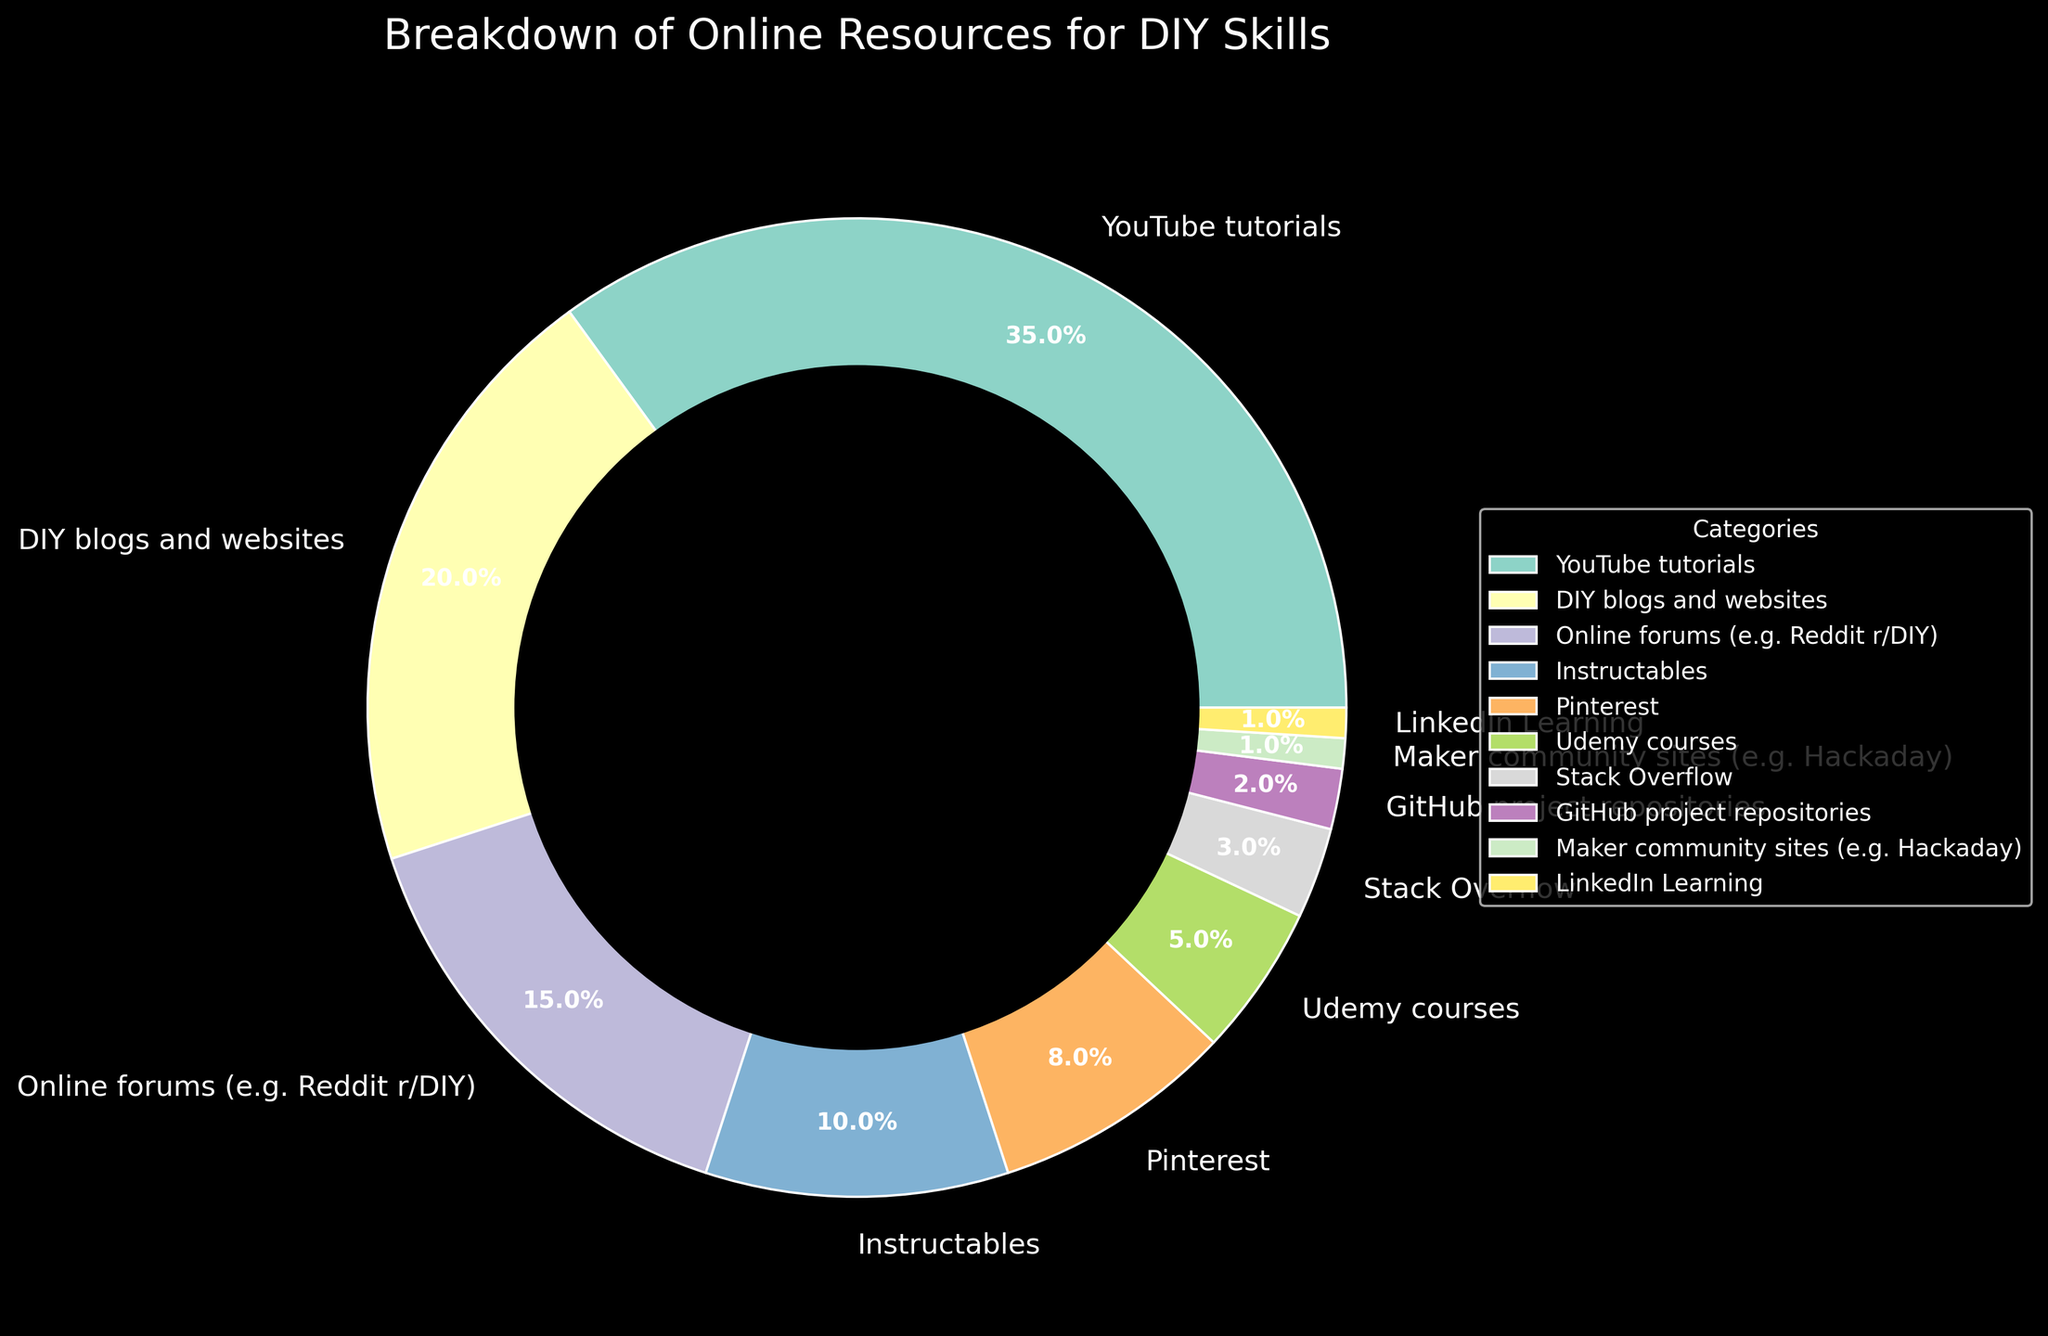What's the combined percentage of YouTube tutorials and DIY blogs and websites? YouTube tutorials account for 35% and DIY blogs and websites account for 20%. To find the combined percentage, add these two values together: 35% + 20% = 55%.
Answer: 55% Which online resource has the smallest percentage? The figure shows that LinkedIn Learning and Maker community sites (e.g., Hackaday) both have the smallest percentage, at 1%.
Answer: LinkedIn Learning and Maker community sites What is the difference in percentage between Instructables and Stack Overflow? Instructables account for 10% and Stack Overflow accounts for 3%. The difference in percentage is calculated as 10% - 3% = 7%.
Answer: 7% Which online resource category has a higher percentage, Pinterest or Udemy courses? From the figure, Pinterest has an 8% share, while Udemy courses have a 5% share. Therefore, Pinterest has a higher percentage.
Answer: Pinterest How much more popular is YouTube tutorials compared to online forums (e.g., Reddit r/DIY)? YouTube tutorials have a percentage of 35%, and online forums (e.g., Reddit r/DIY) have 15%. The difference is 35% - 15% = 20%.
Answer: 20% What is the total percentage of categories that have a share of 5% or less? The applicable categories are Udemy courses (5%), Stack Overflow (3%), GitHub project repositories (2%), Maker community sites (1%), and LinkedIn Learning (1%). Sum them all: 5% + 3% + 2% + 1% + 1% = 12%.
Answer: 12% Which category is represented by the segment with the third largest percentage? The third largest percentage in the chart is 15%, which corresponds to the online forums (e.g., Reddit r/DIY).
Answer: Online forums What is the combined percentage of the three least used online resource categories? The three least used categories are Maker community sites (1%), LinkedIn Learning (1%), and GitHub project repositories (2%). The combined percentage is 1% + 1% + 2% = 4%.
Answer: 4% 